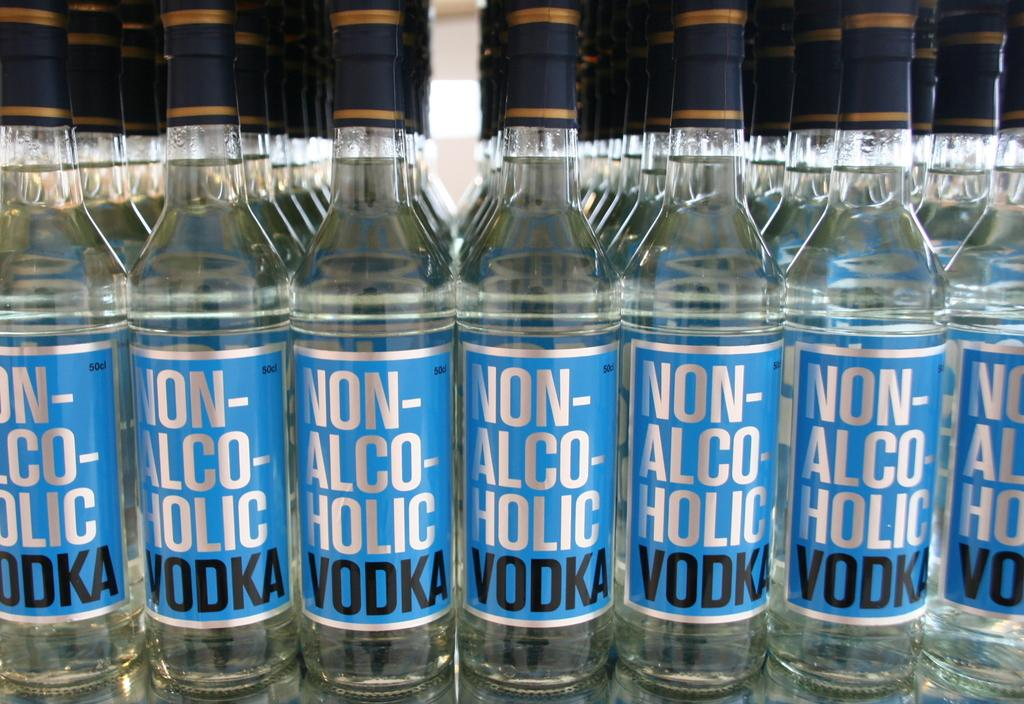What type of objects can be seen in the image? There are multiple bottles in the image. Can you identify any specific type of beverage associated with the bottles? Yes, the word "vodka" is written on at least one of the bottles. What advice is being given on the grass in the image? There is no grass present in the image, and no advice is being given. 